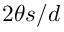<formula> <loc_0><loc_0><loc_500><loc_500>2 \theta s / d</formula> 